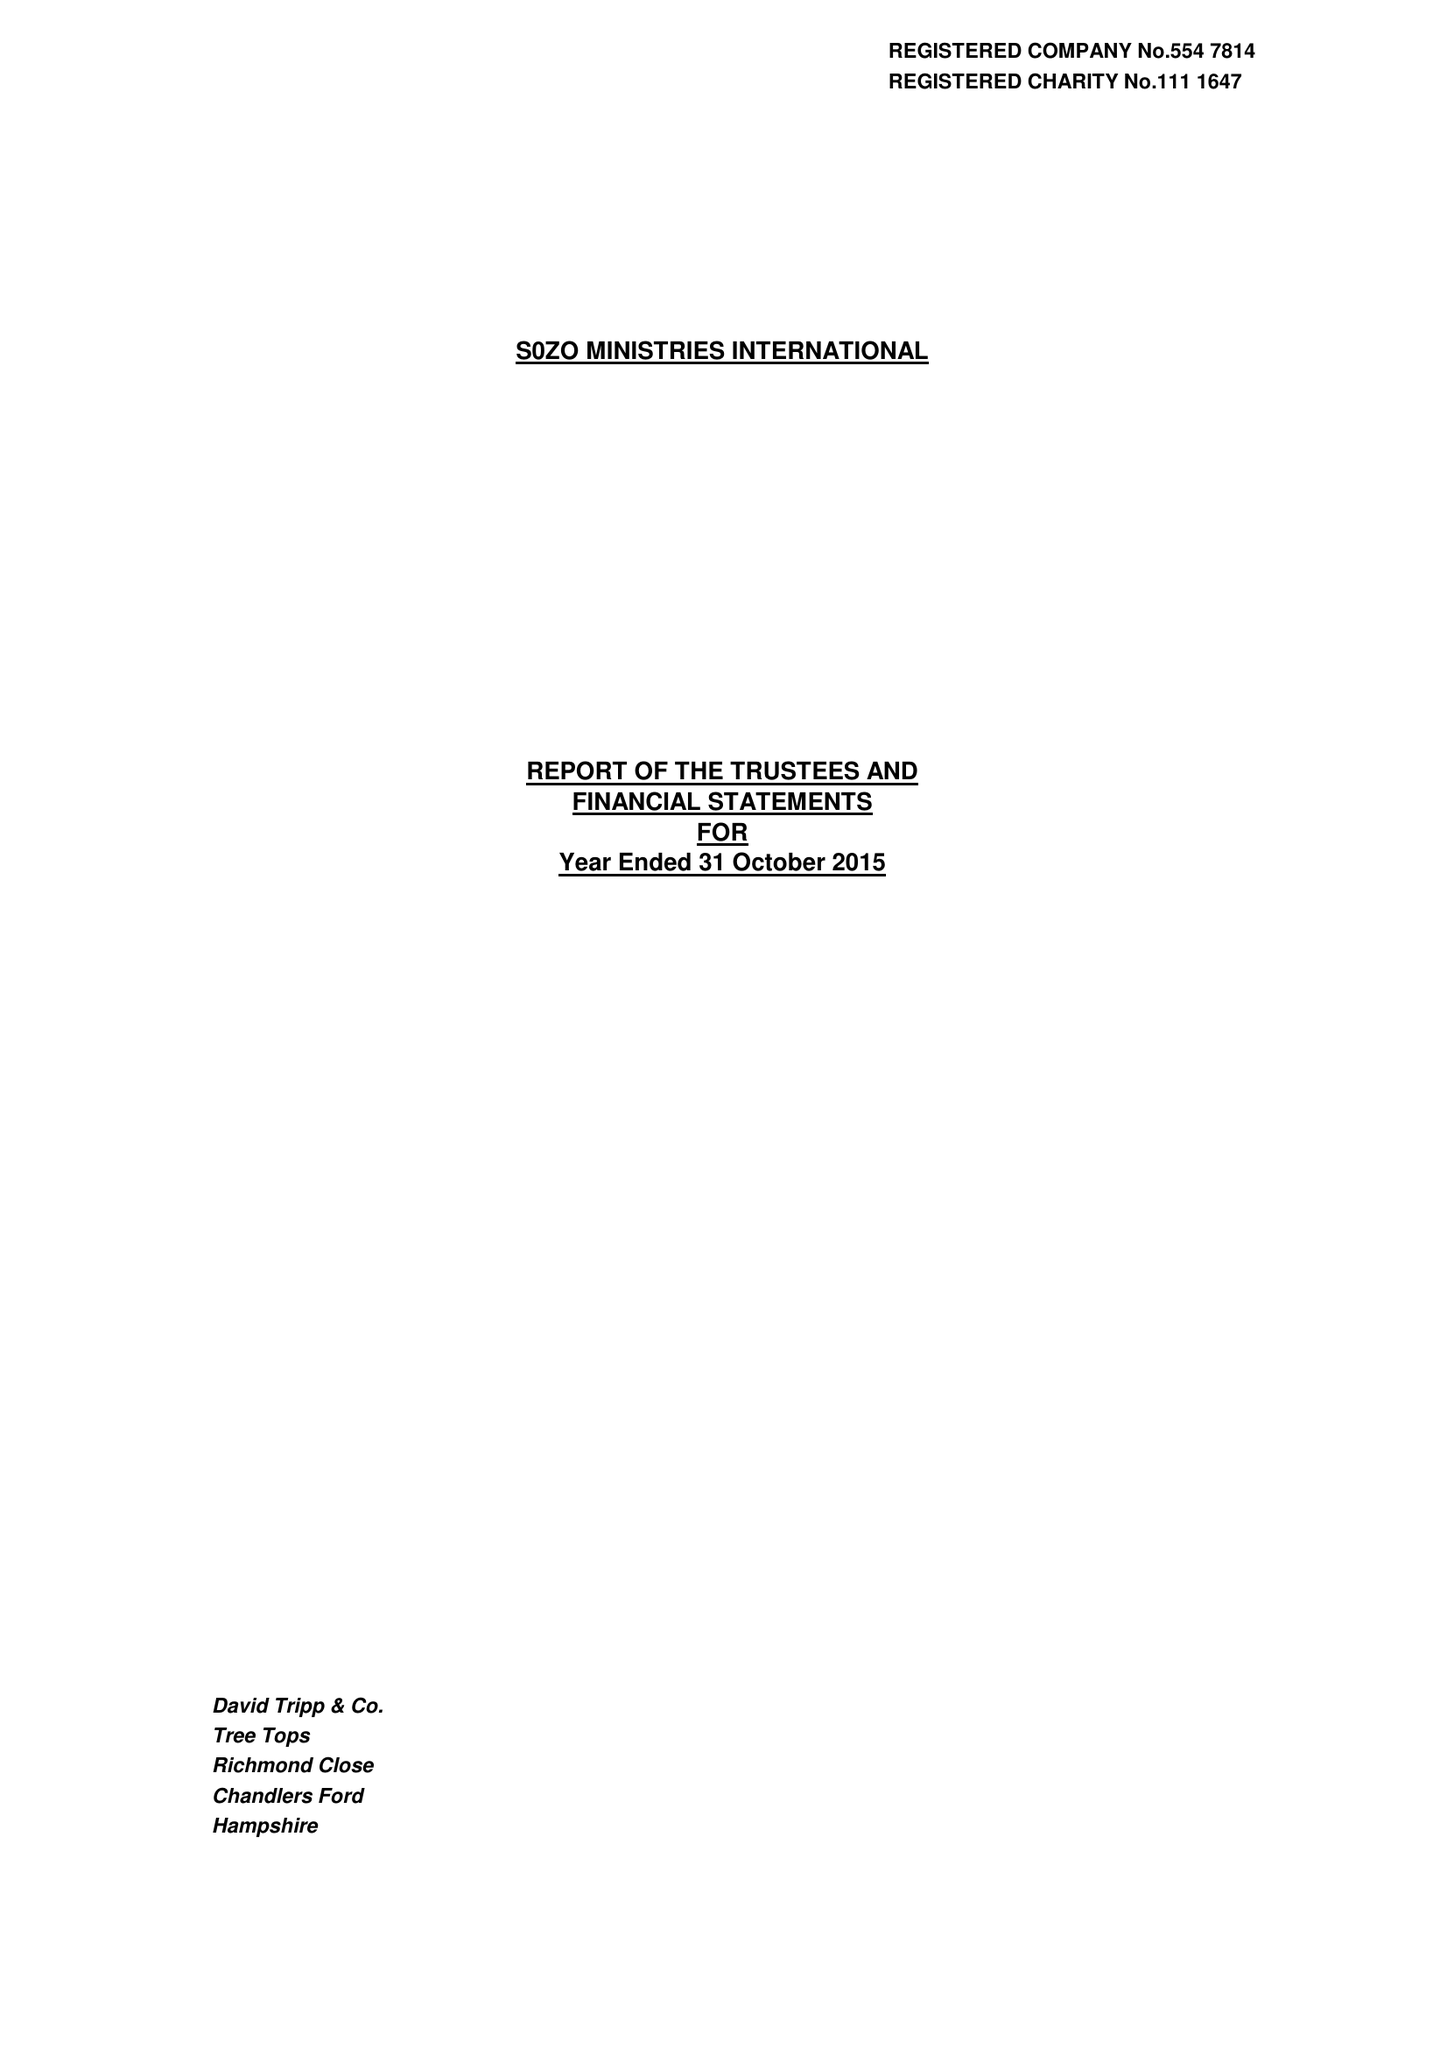What is the value for the report_date?
Answer the question using a single word or phrase. 2015-10-31 